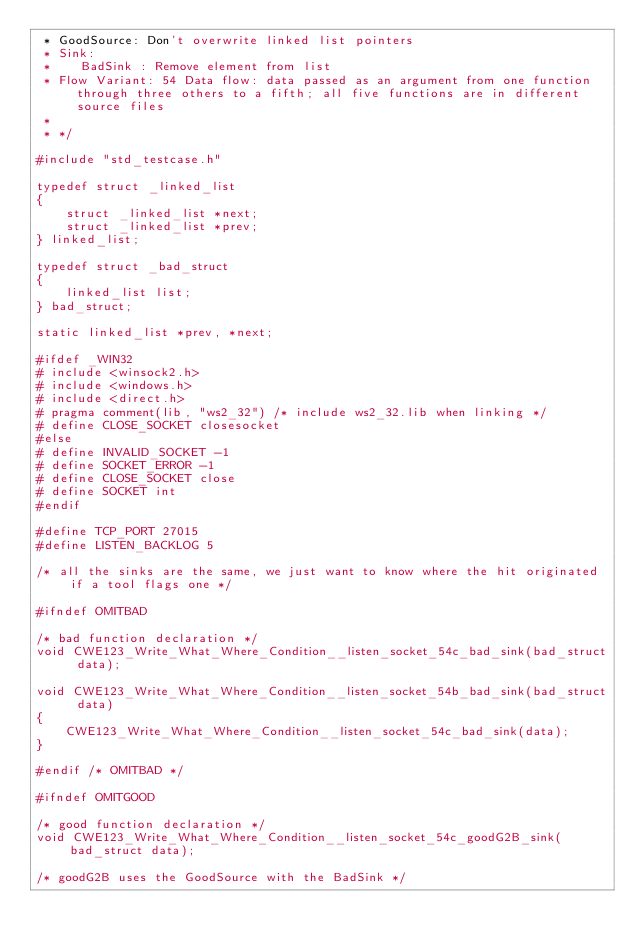<code> <loc_0><loc_0><loc_500><loc_500><_C_> * GoodSource: Don't overwrite linked list pointers
 * Sink:
 *    BadSink : Remove element from list
 * Flow Variant: 54 Data flow: data passed as an argument from one function through three others to a fifth; all five functions are in different source files
 *
 * */

#include "std_testcase.h"

typedef struct _linked_list
{
    struct _linked_list *next;
    struct _linked_list *prev;
} linked_list;

typedef struct _bad_struct
{
    linked_list list;
} bad_struct;

static linked_list *prev, *next;

#ifdef _WIN32
# include <winsock2.h>
# include <windows.h>
# include <direct.h>
# pragma comment(lib, "ws2_32") /* include ws2_32.lib when linking */
# define CLOSE_SOCKET closesocket
#else
# define INVALID_SOCKET -1
# define SOCKET_ERROR -1
# define CLOSE_SOCKET close
# define SOCKET int
#endif

#define TCP_PORT 27015
#define LISTEN_BACKLOG 5

/* all the sinks are the same, we just want to know where the hit originated if a tool flags one */

#ifndef OMITBAD

/* bad function declaration */
void CWE123_Write_What_Where_Condition__listen_socket_54c_bad_sink(bad_struct data);

void CWE123_Write_What_Where_Condition__listen_socket_54b_bad_sink(bad_struct data)
{
    CWE123_Write_What_Where_Condition__listen_socket_54c_bad_sink(data);
}

#endif /* OMITBAD */

#ifndef OMITGOOD

/* good function declaration */
void CWE123_Write_What_Where_Condition__listen_socket_54c_goodG2B_sink(bad_struct data);

/* goodG2B uses the GoodSource with the BadSink */</code> 